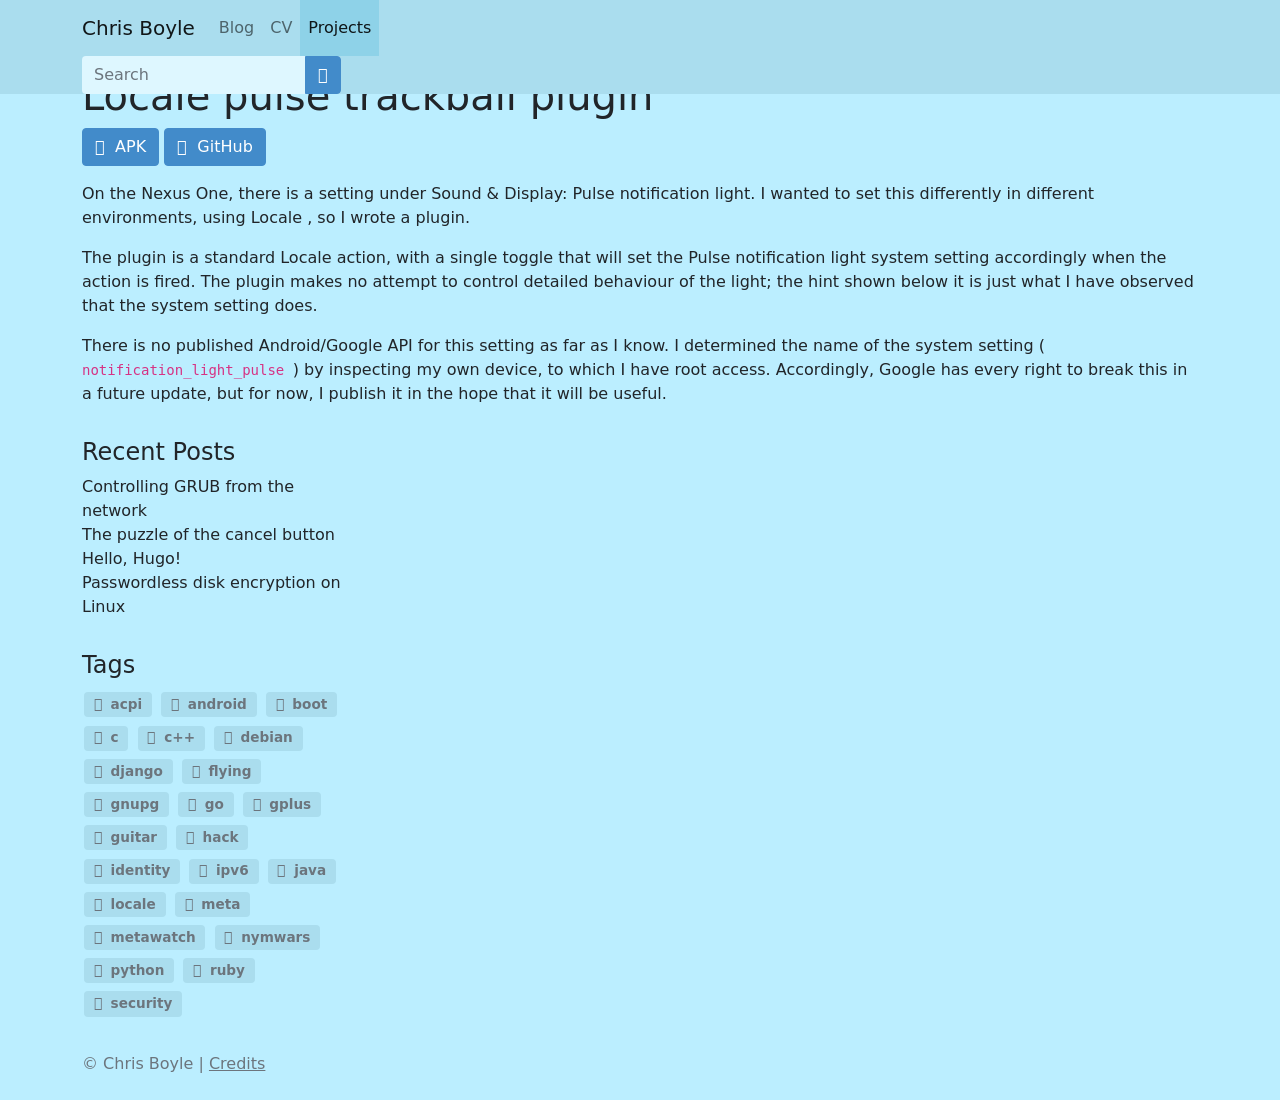Can you tell me more about the 'Locale pulse trackball plugin' mentioned here? Certainly! The 'Locale pulse trackball plugin' is a tool designed for Android devices, particularly the Nexus One, as mentioned on the webpage. It allows users to control the notification light settings through the Locale app, a context-aware settings management application. This plugin can set the pulse notification light to behave differently based on the rules defined in Locale, adjusting it for various environments like being in a meeting or at home. Since it interacts directly with system settings and there's no official API from Google for these settings, it's a useful workaround for users seeking custom notification light behaviors. 